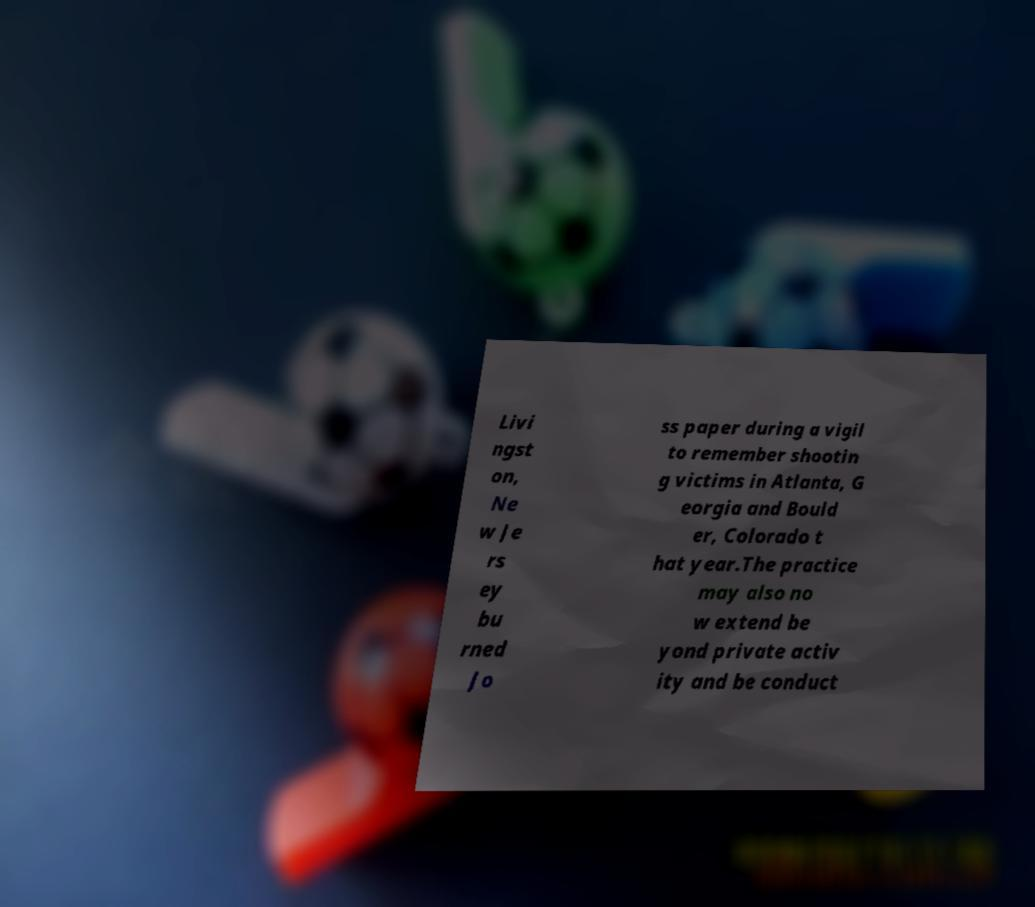Please read and relay the text visible in this image. What does it say? Livi ngst on, Ne w Je rs ey bu rned Jo ss paper during a vigil to remember shootin g victims in Atlanta, G eorgia and Bould er, Colorado t hat year.The practice may also no w extend be yond private activ ity and be conduct 